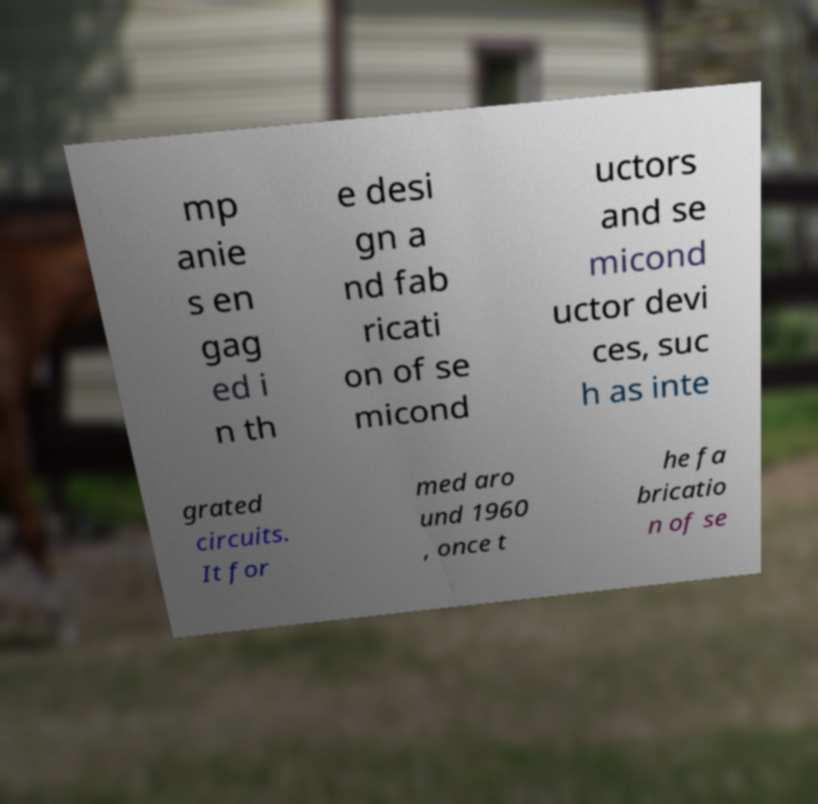Could you assist in decoding the text presented in this image and type it out clearly? mp anie s en gag ed i n th e desi gn a nd fab ricati on of se micond uctors and se micond uctor devi ces, suc h as inte grated circuits. It for med aro und 1960 , once t he fa bricatio n of se 